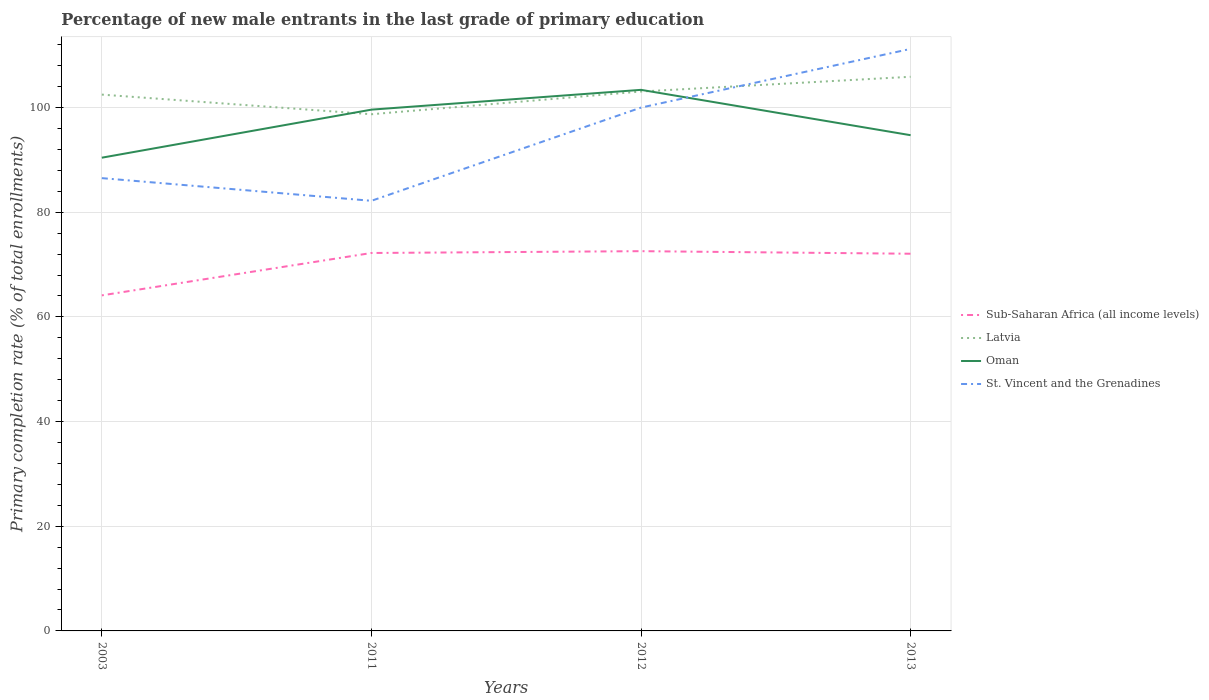Does the line corresponding to Sub-Saharan Africa (all income levels) intersect with the line corresponding to Oman?
Your answer should be compact. No. Across all years, what is the maximum percentage of new male entrants in Latvia?
Offer a terse response. 98.73. In which year was the percentage of new male entrants in Latvia maximum?
Offer a terse response. 2011. What is the total percentage of new male entrants in St. Vincent and the Grenadines in the graph?
Offer a terse response. -13.48. What is the difference between the highest and the second highest percentage of new male entrants in St. Vincent and the Grenadines?
Your answer should be very brief. 29.03. What is the difference between the highest and the lowest percentage of new male entrants in Sub-Saharan Africa (all income levels)?
Provide a succinct answer. 3. Is the percentage of new male entrants in St. Vincent and the Grenadines strictly greater than the percentage of new male entrants in Latvia over the years?
Ensure brevity in your answer.  No. What is the difference between two consecutive major ticks on the Y-axis?
Make the answer very short. 20. Does the graph contain any zero values?
Your answer should be very brief. No. What is the title of the graph?
Give a very brief answer. Percentage of new male entrants in the last grade of primary education. What is the label or title of the X-axis?
Your response must be concise. Years. What is the label or title of the Y-axis?
Offer a very short reply. Primary completion rate (% of total enrollments). What is the Primary completion rate (% of total enrollments) in Sub-Saharan Africa (all income levels) in 2003?
Provide a short and direct response. 64.12. What is the Primary completion rate (% of total enrollments) of Latvia in 2003?
Give a very brief answer. 102.48. What is the Primary completion rate (% of total enrollments) in Oman in 2003?
Make the answer very short. 90.43. What is the Primary completion rate (% of total enrollments) in St. Vincent and the Grenadines in 2003?
Provide a succinct answer. 86.52. What is the Primary completion rate (% of total enrollments) in Sub-Saharan Africa (all income levels) in 2011?
Offer a very short reply. 72.22. What is the Primary completion rate (% of total enrollments) in Latvia in 2011?
Your answer should be compact. 98.73. What is the Primary completion rate (% of total enrollments) of Oman in 2011?
Offer a very short reply. 99.61. What is the Primary completion rate (% of total enrollments) of St. Vincent and the Grenadines in 2011?
Offer a very short reply. 82.19. What is the Primary completion rate (% of total enrollments) in Sub-Saharan Africa (all income levels) in 2012?
Provide a succinct answer. 72.56. What is the Primary completion rate (% of total enrollments) of Latvia in 2012?
Provide a succinct answer. 103.07. What is the Primary completion rate (% of total enrollments) in Oman in 2012?
Offer a very short reply. 103.39. What is the Primary completion rate (% of total enrollments) of St. Vincent and the Grenadines in 2012?
Make the answer very short. 100. What is the Primary completion rate (% of total enrollments) of Sub-Saharan Africa (all income levels) in 2013?
Ensure brevity in your answer.  72.07. What is the Primary completion rate (% of total enrollments) of Latvia in 2013?
Make the answer very short. 105.89. What is the Primary completion rate (% of total enrollments) in Oman in 2013?
Your response must be concise. 94.72. What is the Primary completion rate (% of total enrollments) of St. Vincent and the Grenadines in 2013?
Ensure brevity in your answer.  111.21. Across all years, what is the maximum Primary completion rate (% of total enrollments) in Sub-Saharan Africa (all income levels)?
Your answer should be compact. 72.56. Across all years, what is the maximum Primary completion rate (% of total enrollments) in Latvia?
Ensure brevity in your answer.  105.89. Across all years, what is the maximum Primary completion rate (% of total enrollments) of Oman?
Your answer should be very brief. 103.39. Across all years, what is the maximum Primary completion rate (% of total enrollments) in St. Vincent and the Grenadines?
Your answer should be compact. 111.21. Across all years, what is the minimum Primary completion rate (% of total enrollments) in Sub-Saharan Africa (all income levels)?
Ensure brevity in your answer.  64.12. Across all years, what is the minimum Primary completion rate (% of total enrollments) in Latvia?
Your answer should be compact. 98.73. Across all years, what is the minimum Primary completion rate (% of total enrollments) of Oman?
Your answer should be very brief. 90.43. Across all years, what is the minimum Primary completion rate (% of total enrollments) in St. Vincent and the Grenadines?
Keep it short and to the point. 82.19. What is the total Primary completion rate (% of total enrollments) of Sub-Saharan Africa (all income levels) in the graph?
Offer a very short reply. 280.97. What is the total Primary completion rate (% of total enrollments) of Latvia in the graph?
Make the answer very short. 410.17. What is the total Primary completion rate (% of total enrollments) of Oman in the graph?
Keep it short and to the point. 388.15. What is the total Primary completion rate (% of total enrollments) of St. Vincent and the Grenadines in the graph?
Offer a terse response. 379.92. What is the difference between the Primary completion rate (% of total enrollments) in Sub-Saharan Africa (all income levels) in 2003 and that in 2011?
Provide a short and direct response. -8.1. What is the difference between the Primary completion rate (% of total enrollments) of Latvia in 2003 and that in 2011?
Ensure brevity in your answer.  3.75. What is the difference between the Primary completion rate (% of total enrollments) of Oman in 2003 and that in 2011?
Your answer should be very brief. -9.18. What is the difference between the Primary completion rate (% of total enrollments) in St. Vincent and the Grenadines in 2003 and that in 2011?
Make the answer very short. 4.33. What is the difference between the Primary completion rate (% of total enrollments) of Sub-Saharan Africa (all income levels) in 2003 and that in 2012?
Your response must be concise. -8.45. What is the difference between the Primary completion rate (% of total enrollments) of Latvia in 2003 and that in 2012?
Provide a succinct answer. -0.59. What is the difference between the Primary completion rate (% of total enrollments) of Oman in 2003 and that in 2012?
Offer a terse response. -12.96. What is the difference between the Primary completion rate (% of total enrollments) of St. Vincent and the Grenadines in 2003 and that in 2012?
Your response must be concise. -13.48. What is the difference between the Primary completion rate (% of total enrollments) of Sub-Saharan Africa (all income levels) in 2003 and that in 2013?
Keep it short and to the point. -7.96. What is the difference between the Primary completion rate (% of total enrollments) in Latvia in 2003 and that in 2013?
Make the answer very short. -3.41. What is the difference between the Primary completion rate (% of total enrollments) in Oman in 2003 and that in 2013?
Give a very brief answer. -4.3. What is the difference between the Primary completion rate (% of total enrollments) in St. Vincent and the Grenadines in 2003 and that in 2013?
Offer a very short reply. -24.69. What is the difference between the Primary completion rate (% of total enrollments) in Sub-Saharan Africa (all income levels) in 2011 and that in 2012?
Offer a very short reply. -0.35. What is the difference between the Primary completion rate (% of total enrollments) in Latvia in 2011 and that in 2012?
Ensure brevity in your answer.  -4.34. What is the difference between the Primary completion rate (% of total enrollments) of Oman in 2011 and that in 2012?
Ensure brevity in your answer.  -3.78. What is the difference between the Primary completion rate (% of total enrollments) in St. Vincent and the Grenadines in 2011 and that in 2012?
Ensure brevity in your answer.  -17.81. What is the difference between the Primary completion rate (% of total enrollments) of Sub-Saharan Africa (all income levels) in 2011 and that in 2013?
Make the answer very short. 0.14. What is the difference between the Primary completion rate (% of total enrollments) in Latvia in 2011 and that in 2013?
Make the answer very short. -7.16. What is the difference between the Primary completion rate (% of total enrollments) in Oman in 2011 and that in 2013?
Your answer should be very brief. 4.88. What is the difference between the Primary completion rate (% of total enrollments) in St. Vincent and the Grenadines in 2011 and that in 2013?
Make the answer very short. -29.03. What is the difference between the Primary completion rate (% of total enrollments) in Sub-Saharan Africa (all income levels) in 2012 and that in 2013?
Make the answer very short. 0.49. What is the difference between the Primary completion rate (% of total enrollments) in Latvia in 2012 and that in 2013?
Provide a short and direct response. -2.82. What is the difference between the Primary completion rate (% of total enrollments) in Oman in 2012 and that in 2013?
Provide a succinct answer. 8.67. What is the difference between the Primary completion rate (% of total enrollments) in St. Vincent and the Grenadines in 2012 and that in 2013?
Offer a very short reply. -11.21. What is the difference between the Primary completion rate (% of total enrollments) of Sub-Saharan Africa (all income levels) in 2003 and the Primary completion rate (% of total enrollments) of Latvia in 2011?
Give a very brief answer. -34.61. What is the difference between the Primary completion rate (% of total enrollments) in Sub-Saharan Africa (all income levels) in 2003 and the Primary completion rate (% of total enrollments) in Oman in 2011?
Make the answer very short. -35.49. What is the difference between the Primary completion rate (% of total enrollments) in Sub-Saharan Africa (all income levels) in 2003 and the Primary completion rate (% of total enrollments) in St. Vincent and the Grenadines in 2011?
Your answer should be compact. -18.07. What is the difference between the Primary completion rate (% of total enrollments) of Latvia in 2003 and the Primary completion rate (% of total enrollments) of Oman in 2011?
Keep it short and to the point. 2.87. What is the difference between the Primary completion rate (% of total enrollments) in Latvia in 2003 and the Primary completion rate (% of total enrollments) in St. Vincent and the Grenadines in 2011?
Offer a terse response. 20.29. What is the difference between the Primary completion rate (% of total enrollments) of Oman in 2003 and the Primary completion rate (% of total enrollments) of St. Vincent and the Grenadines in 2011?
Make the answer very short. 8.24. What is the difference between the Primary completion rate (% of total enrollments) of Sub-Saharan Africa (all income levels) in 2003 and the Primary completion rate (% of total enrollments) of Latvia in 2012?
Provide a short and direct response. -38.95. What is the difference between the Primary completion rate (% of total enrollments) in Sub-Saharan Africa (all income levels) in 2003 and the Primary completion rate (% of total enrollments) in Oman in 2012?
Provide a short and direct response. -39.27. What is the difference between the Primary completion rate (% of total enrollments) of Sub-Saharan Africa (all income levels) in 2003 and the Primary completion rate (% of total enrollments) of St. Vincent and the Grenadines in 2012?
Offer a terse response. -35.88. What is the difference between the Primary completion rate (% of total enrollments) of Latvia in 2003 and the Primary completion rate (% of total enrollments) of Oman in 2012?
Your response must be concise. -0.91. What is the difference between the Primary completion rate (% of total enrollments) of Latvia in 2003 and the Primary completion rate (% of total enrollments) of St. Vincent and the Grenadines in 2012?
Make the answer very short. 2.48. What is the difference between the Primary completion rate (% of total enrollments) of Oman in 2003 and the Primary completion rate (% of total enrollments) of St. Vincent and the Grenadines in 2012?
Your response must be concise. -9.57. What is the difference between the Primary completion rate (% of total enrollments) in Sub-Saharan Africa (all income levels) in 2003 and the Primary completion rate (% of total enrollments) in Latvia in 2013?
Your answer should be very brief. -41.77. What is the difference between the Primary completion rate (% of total enrollments) of Sub-Saharan Africa (all income levels) in 2003 and the Primary completion rate (% of total enrollments) of Oman in 2013?
Your answer should be very brief. -30.6. What is the difference between the Primary completion rate (% of total enrollments) of Sub-Saharan Africa (all income levels) in 2003 and the Primary completion rate (% of total enrollments) of St. Vincent and the Grenadines in 2013?
Your answer should be compact. -47.1. What is the difference between the Primary completion rate (% of total enrollments) in Latvia in 2003 and the Primary completion rate (% of total enrollments) in Oman in 2013?
Make the answer very short. 7.76. What is the difference between the Primary completion rate (% of total enrollments) of Latvia in 2003 and the Primary completion rate (% of total enrollments) of St. Vincent and the Grenadines in 2013?
Offer a very short reply. -8.73. What is the difference between the Primary completion rate (% of total enrollments) in Oman in 2003 and the Primary completion rate (% of total enrollments) in St. Vincent and the Grenadines in 2013?
Ensure brevity in your answer.  -20.79. What is the difference between the Primary completion rate (% of total enrollments) of Sub-Saharan Africa (all income levels) in 2011 and the Primary completion rate (% of total enrollments) of Latvia in 2012?
Offer a very short reply. -30.85. What is the difference between the Primary completion rate (% of total enrollments) of Sub-Saharan Africa (all income levels) in 2011 and the Primary completion rate (% of total enrollments) of Oman in 2012?
Provide a short and direct response. -31.17. What is the difference between the Primary completion rate (% of total enrollments) in Sub-Saharan Africa (all income levels) in 2011 and the Primary completion rate (% of total enrollments) in St. Vincent and the Grenadines in 2012?
Offer a very short reply. -27.78. What is the difference between the Primary completion rate (% of total enrollments) in Latvia in 2011 and the Primary completion rate (% of total enrollments) in Oman in 2012?
Offer a very short reply. -4.66. What is the difference between the Primary completion rate (% of total enrollments) in Latvia in 2011 and the Primary completion rate (% of total enrollments) in St. Vincent and the Grenadines in 2012?
Ensure brevity in your answer.  -1.27. What is the difference between the Primary completion rate (% of total enrollments) of Oman in 2011 and the Primary completion rate (% of total enrollments) of St. Vincent and the Grenadines in 2012?
Give a very brief answer. -0.39. What is the difference between the Primary completion rate (% of total enrollments) of Sub-Saharan Africa (all income levels) in 2011 and the Primary completion rate (% of total enrollments) of Latvia in 2013?
Your response must be concise. -33.67. What is the difference between the Primary completion rate (% of total enrollments) of Sub-Saharan Africa (all income levels) in 2011 and the Primary completion rate (% of total enrollments) of Oman in 2013?
Your answer should be very brief. -22.51. What is the difference between the Primary completion rate (% of total enrollments) in Sub-Saharan Africa (all income levels) in 2011 and the Primary completion rate (% of total enrollments) in St. Vincent and the Grenadines in 2013?
Your response must be concise. -39. What is the difference between the Primary completion rate (% of total enrollments) in Latvia in 2011 and the Primary completion rate (% of total enrollments) in Oman in 2013?
Give a very brief answer. 4.01. What is the difference between the Primary completion rate (% of total enrollments) in Latvia in 2011 and the Primary completion rate (% of total enrollments) in St. Vincent and the Grenadines in 2013?
Make the answer very short. -12.48. What is the difference between the Primary completion rate (% of total enrollments) of Oman in 2011 and the Primary completion rate (% of total enrollments) of St. Vincent and the Grenadines in 2013?
Provide a short and direct response. -11.61. What is the difference between the Primary completion rate (% of total enrollments) of Sub-Saharan Africa (all income levels) in 2012 and the Primary completion rate (% of total enrollments) of Latvia in 2013?
Your answer should be compact. -33.32. What is the difference between the Primary completion rate (% of total enrollments) in Sub-Saharan Africa (all income levels) in 2012 and the Primary completion rate (% of total enrollments) in Oman in 2013?
Your response must be concise. -22.16. What is the difference between the Primary completion rate (% of total enrollments) in Sub-Saharan Africa (all income levels) in 2012 and the Primary completion rate (% of total enrollments) in St. Vincent and the Grenadines in 2013?
Keep it short and to the point. -38.65. What is the difference between the Primary completion rate (% of total enrollments) in Latvia in 2012 and the Primary completion rate (% of total enrollments) in Oman in 2013?
Keep it short and to the point. 8.35. What is the difference between the Primary completion rate (% of total enrollments) of Latvia in 2012 and the Primary completion rate (% of total enrollments) of St. Vincent and the Grenadines in 2013?
Ensure brevity in your answer.  -8.14. What is the difference between the Primary completion rate (% of total enrollments) of Oman in 2012 and the Primary completion rate (% of total enrollments) of St. Vincent and the Grenadines in 2013?
Give a very brief answer. -7.82. What is the average Primary completion rate (% of total enrollments) in Sub-Saharan Africa (all income levels) per year?
Make the answer very short. 70.24. What is the average Primary completion rate (% of total enrollments) in Latvia per year?
Offer a terse response. 102.54. What is the average Primary completion rate (% of total enrollments) of Oman per year?
Make the answer very short. 97.04. What is the average Primary completion rate (% of total enrollments) in St. Vincent and the Grenadines per year?
Your answer should be compact. 94.98. In the year 2003, what is the difference between the Primary completion rate (% of total enrollments) in Sub-Saharan Africa (all income levels) and Primary completion rate (% of total enrollments) in Latvia?
Provide a succinct answer. -38.36. In the year 2003, what is the difference between the Primary completion rate (% of total enrollments) of Sub-Saharan Africa (all income levels) and Primary completion rate (% of total enrollments) of Oman?
Your response must be concise. -26.31. In the year 2003, what is the difference between the Primary completion rate (% of total enrollments) of Sub-Saharan Africa (all income levels) and Primary completion rate (% of total enrollments) of St. Vincent and the Grenadines?
Make the answer very short. -22.4. In the year 2003, what is the difference between the Primary completion rate (% of total enrollments) in Latvia and Primary completion rate (% of total enrollments) in Oman?
Keep it short and to the point. 12.05. In the year 2003, what is the difference between the Primary completion rate (% of total enrollments) of Latvia and Primary completion rate (% of total enrollments) of St. Vincent and the Grenadines?
Your answer should be compact. 15.96. In the year 2003, what is the difference between the Primary completion rate (% of total enrollments) in Oman and Primary completion rate (% of total enrollments) in St. Vincent and the Grenadines?
Offer a terse response. 3.91. In the year 2011, what is the difference between the Primary completion rate (% of total enrollments) of Sub-Saharan Africa (all income levels) and Primary completion rate (% of total enrollments) of Latvia?
Keep it short and to the point. -26.51. In the year 2011, what is the difference between the Primary completion rate (% of total enrollments) of Sub-Saharan Africa (all income levels) and Primary completion rate (% of total enrollments) of Oman?
Offer a terse response. -27.39. In the year 2011, what is the difference between the Primary completion rate (% of total enrollments) of Sub-Saharan Africa (all income levels) and Primary completion rate (% of total enrollments) of St. Vincent and the Grenadines?
Your answer should be compact. -9.97. In the year 2011, what is the difference between the Primary completion rate (% of total enrollments) of Latvia and Primary completion rate (% of total enrollments) of Oman?
Offer a very short reply. -0.88. In the year 2011, what is the difference between the Primary completion rate (% of total enrollments) in Latvia and Primary completion rate (% of total enrollments) in St. Vincent and the Grenadines?
Give a very brief answer. 16.54. In the year 2011, what is the difference between the Primary completion rate (% of total enrollments) in Oman and Primary completion rate (% of total enrollments) in St. Vincent and the Grenadines?
Your answer should be compact. 17.42. In the year 2012, what is the difference between the Primary completion rate (% of total enrollments) of Sub-Saharan Africa (all income levels) and Primary completion rate (% of total enrollments) of Latvia?
Provide a succinct answer. -30.51. In the year 2012, what is the difference between the Primary completion rate (% of total enrollments) in Sub-Saharan Africa (all income levels) and Primary completion rate (% of total enrollments) in Oman?
Offer a terse response. -30.83. In the year 2012, what is the difference between the Primary completion rate (% of total enrollments) in Sub-Saharan Africa (all income levels) and Primary completion rate (% of total enrollments) in St. Vincent and the Grenadines?
Make the answer very short. -27.44. In the year 2012, what is the difference between the Primary completion rate (% of total enrollments) of Latvia and Primary completion rate (% of total enrollments) of Oman?
Your answer should be compact. -0.32. In the year 2012, what is the difference between the Primary completion rate (% of total enrollments) of Latvia and Primary completion rate (% of total enrollments) of St. Vincent and the Grenadines?
Keep it short and to the point. 3.07. In the year 2012, what is the difference between the Primary completion rate (% of total enrollments) of Oman and Primary completion rate (% of total enrollments) of St. Vincent and the Grenadines?
Provide a succinct answer. 3.39. In the year 2013, what is the difference between the Primary completion rate (% of total enrollments) in Sub-Saharan Africa (all income levels) and Primary completion rate (% of total enrollments) in Latvia?
Offer a terse response. -33.81. In the year 2013, what is the difference between the Primary completion rate (% of total enrollments) in Sub-Saharan Africa (all income levels) and Primary completion rate (% of total enrollments) in Oman?
Your response must be concise. -22.65. In the year 2013, what is the difference between the Primary completion rate (% of total enrollments) in Sub-Saharan Africa (all income levels) and Primary completion rate (% of total enrollments) in St. Vincent and the Grenadines?
Provide a succinct answer. -39.14. In the year 2013, what is the difference between the Primary completion rate (% of total enrollments) of Latvia and Primary completion rate (% of total enrollments) of Oman?
Your answer should be very brief. 11.16. In the year 2013, what is the difference between the Primary completion rate (% of total enrollments) of Latvia and Primary completion rate (% of total enrollments) of St. Vincent and the Grenadines?
Offer a very short reply. -5.33. In the year 2013, what is the difference between the Primary completion rate (% of total enrollments) in Oman and Primary completion rate (% of total enrollments) in St. Vincent and the Grenadines?
Offer a very short reply. -16.49. What is the ratio of the Primary completion rate (% of total enrollments) in Sub-Saharan Africa (all income levels) in 2003 to that in 2011?
Keep it short and to the point. 0.89. What is the ratio of the Primary completion rate (% of total enrollments) in Latvia in 2003 to that in 2011?
Make the answer very short. 1.04. What is the ratio of the Primary completion rate (% of total enrollments) in Oman in 2003 to that in 2011?
Offer a very short reply. 0.91. What is the ratio of the Primary completion rate (% of total enrollments) of St. Vincent and the Grenadines in 2003 to that in 2011?
Keep it short and to the point. 1.05. What is the ratio of the Primary completion rate (% of total enrollments) of Sub-Saharan Africa (all income levels) in 2003 to that in 2012?
Your response must be concise. 0.88. What is the ratio of the Primary completion rate (% of total enrollments) of Oman in 2003 to that in 2012?
Keep it short and to the point. 0.87. What is the ratio of the Primary completion rate (% of total enrollments) of St. Vincent and the Grenadines in 2003 to that in 2012?
Give a very brief answer. 0.87. What is the ratio of the Primary completion rate (% of total enrollments) of Sub-Saharan Africa (all income levels) in 2003 to that in 2013?
Your response must be concise. 0.89. What is the ratio of the Primary completion rate (% of total enrollments) in Latvia in 2003 to that in 2013?
Provide a succinct answer. 0.97. What is the ratio of the Primary completion rate (% of total enrollments) of Oman in 2003 to that in 2013?
Ensure brevity in your answer.  0.95. What is the ratio of the Primary completion rate (% of total enrollments) of St. Vincent and the Grenadines in 2003 to that in 2013?
Provide a short and direct response. 0.78. What is the ratio of the Primary completion rate (% of total enrollments) in Latvia in 2011 to that in 2012?
Keep it short and to the point. 0.96. What is the ratio of the Primary completion rate (% of total enrollments) of Oman in 2011 to that in 2012?
Your answer should be compact. 0.96. What is the ratio of the Primary completion rate (% of total enrollments) in St. Vincent and the Grenadines in 2011 to that in 2012?
Your answer should be very brief. 0.82. What is the ratio of the Primary completion rate (% of total enrollments) of Sub-Saharan Africa (all income levels) in 2011 to that in 2013?
Offer a very short reply. 1. What is the ratio of the Primary completion rate (% of total enrollments) of Latvia in 2011 to that in 2013?
Your answer should be very brief. 0.93. What is the ratio of the Primary completion rate (% of total enrollments) in Oman in 2011 to that in 2013?
Offer a very short reply. 1.05. What is the ratio of the Primary completion rate (% of total enrollments) in St. Vincent and the Grenadines in 2011 to that in 2013?
Ensure brevity in your answer.  0.74. What is the ratio of the Primary completion rate (% of total enrollments) of Sub-Saharan Africa (all income levels) in 2012 to that in 2013?
Give a very brief answer. 1.01. What is the ratio of the Primary completion rate (% of total enrollments) of Latvia in 2012 to that in 2013?
Provide a short and direct response. 0.97. What is the ratio of the Primary completion rate (% of total enrollments) of Oman in 2012 to that in 2013?
Your answer should be compact. 1.09. What is the ratio of the Primary completion rate (% of total enrollments) of St. Vincent and the Grenadines in 2012 to that in 2013?
Offer a very short reply. 0.9. What is the difference between the highest and the second highest Primary completion rate (% of total enrollments) in Sub-Saharan Africa (all income levels)?
Make the answer very short. 0.35. What is the difference between the highest and the second highest Primary completion rate (% of total enrollments) in Latvia?
Keep it short and to the point. 2.82. What is the difference between the highest and the second highest Primary completion rate (% of total enrollments) in Oman?
Give a very brief answer. 3.78. What is the difference between the highest and the second highest Primary completion rate (% of total enrollments) of St. Vincent and the Grenadines?
Give a very brief answer. 11.21. What is the difference between the highest and the lowest Primary completion rate (% of total enrollments) of Sub-Saharan Africa (all income levels)?
Your answer should be very brief. 8.45. What is the difference between the highest and the lowest Primary completion rate (% of total enrollments) of Latvia?
Offer a very short reply. 7.16. What is the difference between the highest and the lowest Primary completion rate (% of total enrollments) in Oman?
Your answer should be compact. 12.96. What is the difference between the highest and the lowest Primary completion rate (% of total enrollments) of St. Vincent and the Grenadines?
Provide a succinct answer. 29.03. 